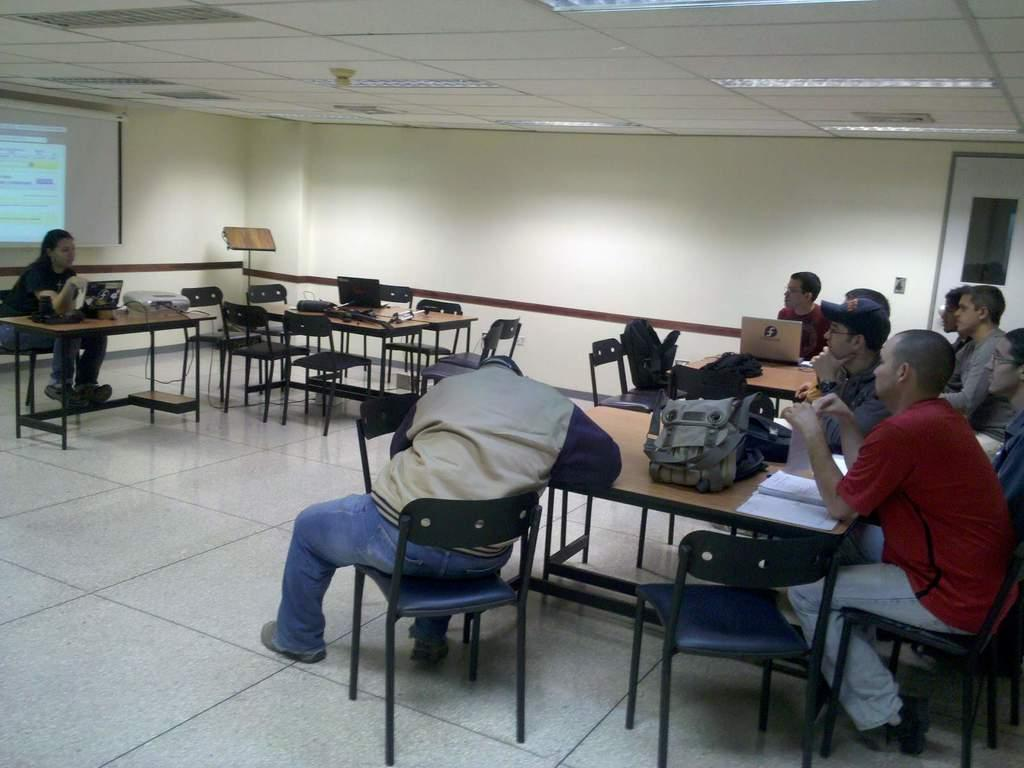What type of furniture is present in the image? There are chairs and tables in the image. What are the people in the image doing? There are people sitting in front of the tables in the image. What items can be seen on the tables? There are backpacks and laptops on the tables in the image. How far away is the plough from the people in the image? There is no plough present in the image. What is the distance between the cent and the laptop in the image? There is no cent present in the image, and the distance between objects cannot be determined from a 2D image. 